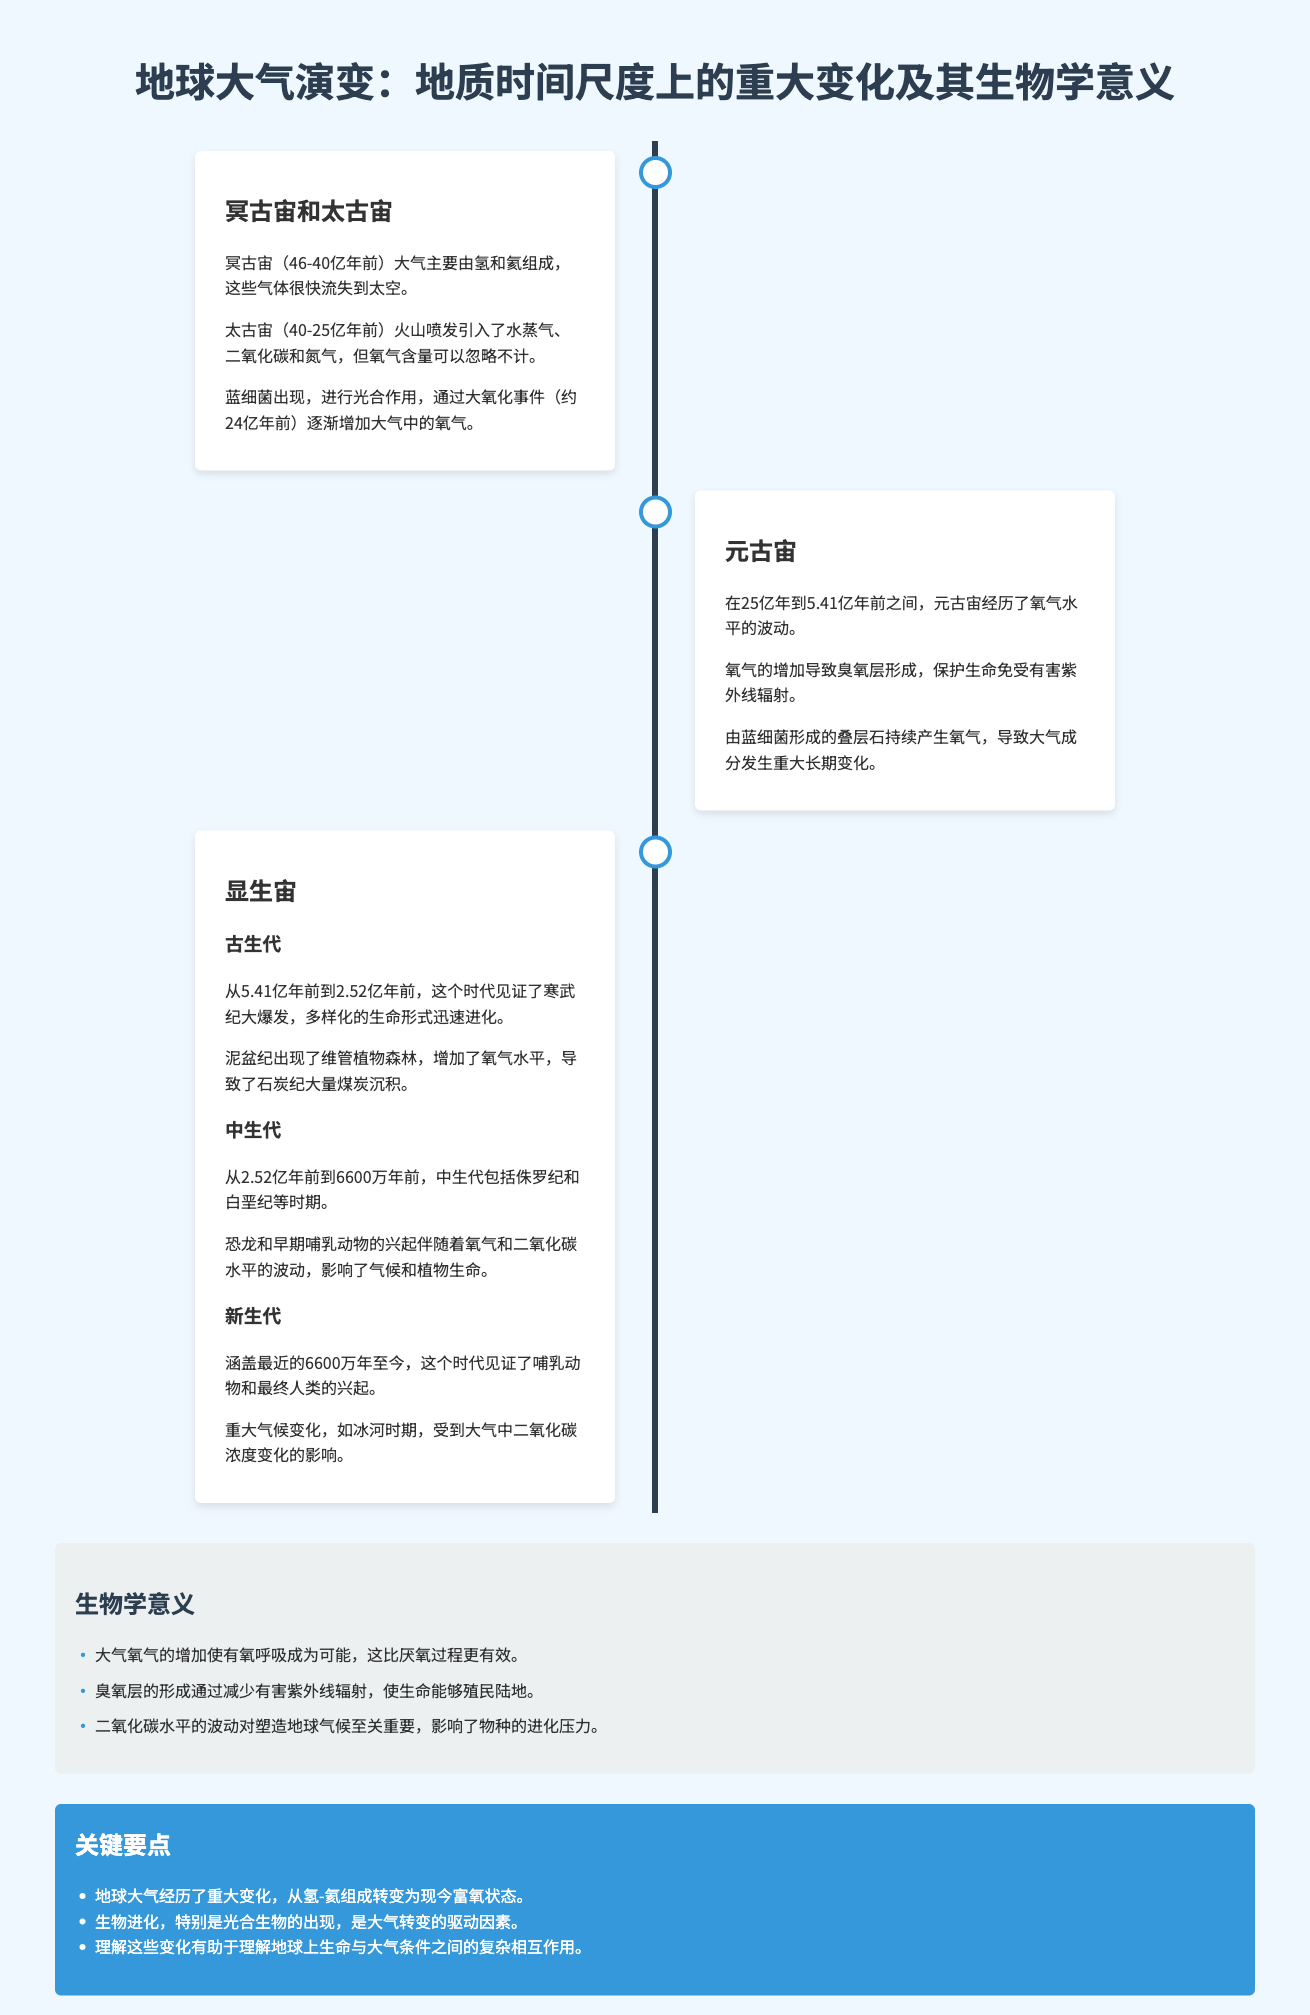What are the two main gases in the atmosphere during the Hadean Eon? The atmosphere primarily consisted of hydrogen and helium during the Hadean Eon.
Answer: hydrogen and helium When did the Great Oxidation Event occur? The Great Oxidation Event occurred approximately 2.4 billion years ago.
Answer: 2.4 billion years ago What major biological event happened in the Cambrian period? The Cambrian explosion marked a rapid diversification of life forms during the Cambrian period.
Answer: Cambrian explosion What geological era follows the Proterozoic? The Phanerozoic era follows the Proterozoic era.
Answer: Phanerozoic How did the increase in oxygen levels affect the Earth’s atmosphere? The increase in oxygen levels led to the formation of the ozone layer that protects life from harmful UV radiation.
Answer: formation of the ozone layer What were the two main types of plants that emerged during the Devonian period? The appearance of vascular plants dominated the forests during the Devonian period.
Answer: vascular plants How did carbon dioxide levels impact species evolution? Fluctuations in carbon dioxide levels shaped the Earth's climate and influenced evolutionary pressures on species.
Answer: shaped Earth's climate What is the impact of the ozone layer according to the infographic? The ozone layer protects life by reducing harmful ultraviolet radiation exposure.
Answer: reduces harmful ultraviolet radiation What time span does the Mesozoic Era cover? The Mesozoic Era spans from 252 million to 66 million years ago.
Answer: 252 million to 66 million years ago 